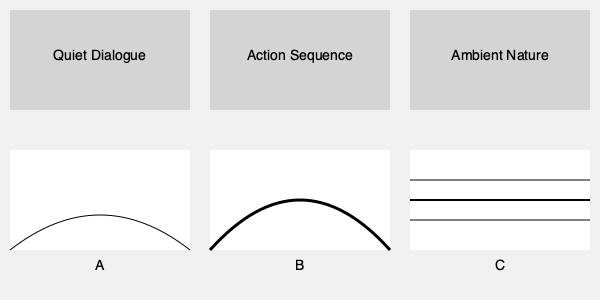Match the visual film scenes with their corresponding audio spectrograms. Which spectrogram (A, B, or C) best represents the sound profile of the "Action Sequence" scene? To match the visual film scenes with their corresponding audio spectrograms, we need to analyze the characteristics of each scene and spectrogram:

1. Quiet Dialogue scene:
   - Typically has a low-intensity, narrow frequency range
   - Would correspond to a spectrogram with subtle, low-amplitude patterns

2. Action Sequence scene:
   - Features intense, dynamic audio with a wide range of frequencies
   - Would correspond to a spectrogram with high-amplitude, varied patterns

3. Ambient Nature scene:
   - Often contains consistent background sounds across a moderate frequency range
   - Would correspond to a spectrogram with steady, mid-level patterns

Analyzing the spectrograms:

A: Shows a gentle, low-amplitude curve, suitable for quiet dialogue
B: Displays a high-amplitude, varied pattern, indicating intense and dynamic audio
C: Presents steady, parallel lines, suggesting consistent background sounds

The "Action Sequence" scene would require a spectrogram that represents intense, varied audio across a wide frequency range. Spectrogram B best fits this description with its high-amplitude and dynamic pattern.
Answer: B 